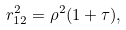<formula> <loc_0><loc_0><loc_500><loc_500>r ^ { 2 } _ { 1 2 } = { \rho } ^ { 2 } ( 1 + \tau ) ,</formula> 